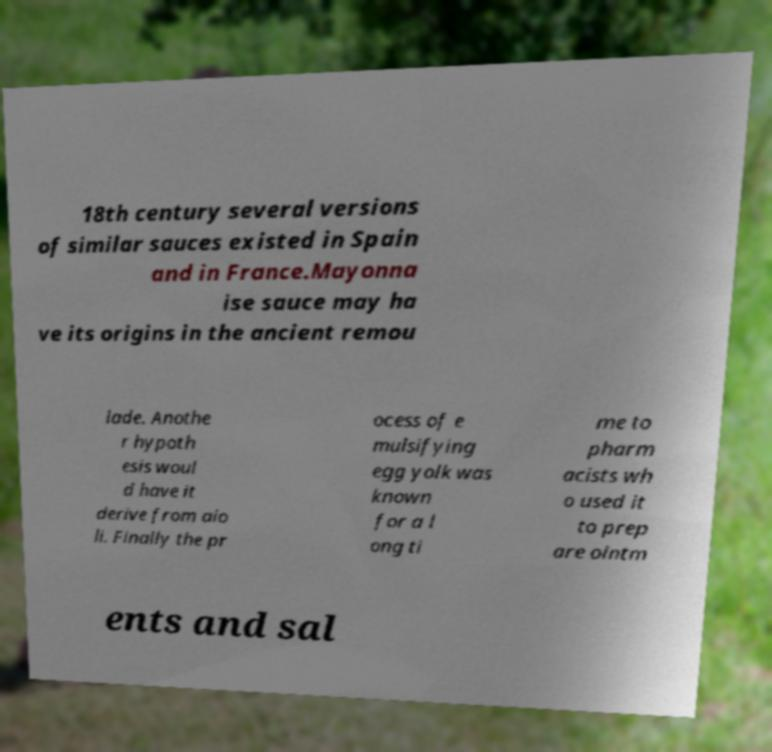Please identify and transcribe the text found in this image. 18th century several versions of similar sauces existed in Spain and in France.Mayonna ise sauce may ha ve its origins in the ancient remou lade. Anothe r hypoth esis woul d have it derive from aio li. Finally the pr ocess of e mulsifying egg yolk was known for a l ong ti me to pharm acists wh o used it to prep are ointm ents and sal 